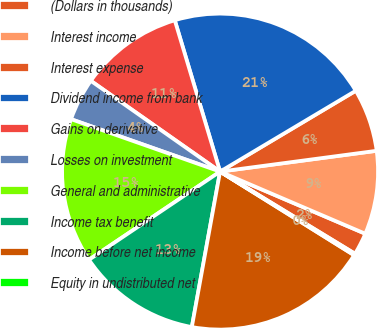Convert chart. <chart><loc_0><loc_0><loc_500><loc_500><pie_chart><fcel>(Dollars in thousands)<fcel>Interest income<fcel>Interest expense<fcel>Dividend income from bank<fcel>Gains on derivative<fcel>Losses on investment<fcel>General and administrative<fcel>Income tax benefit<fcel>Income before net income<fcel>Equity in undistributed net<nl><fcel>2.27%<fcel>8.54%<fcel>6.45%<fcel>21.08%<fcel>10.63%<fcel>4.36%<fcel>14.81%<fcel>12.72%<fcel>18.99%<fcel>0.17%<nl></chart> 